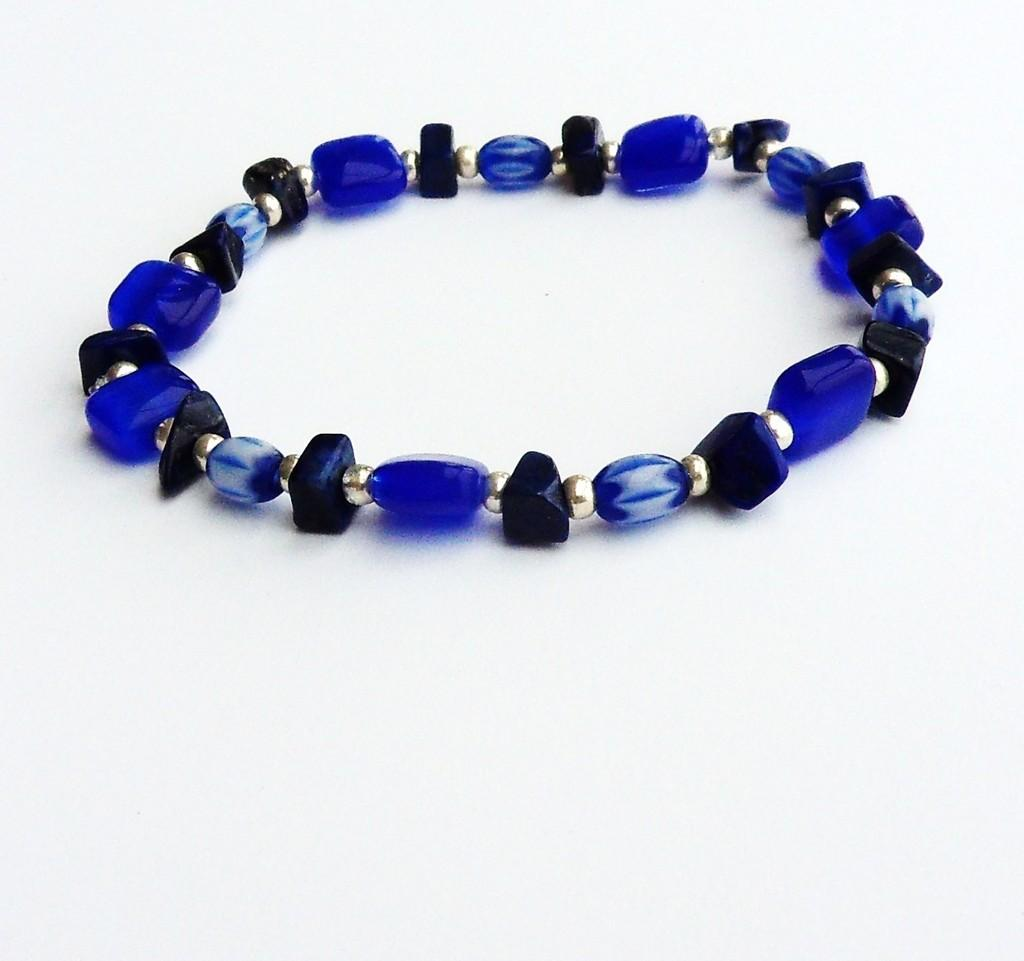What is the main subject of the picture? The main subject of the picture is a bracelet. What color is the bracelet? The bracelet is blue in color. What material is the bracelet made of? The bracelet is made up of silver color beads. What is the color of the background in the picture? The background of the picture is white in color. Can you tell me how many spades are used to create the design of the bracelet? There is no mention of spades being used in the design of the bracelet; it is made up of silver color beads. Is the bracelet being worn on someone's wrist in the image? The image does not show the bracelet being worn on a wrist; it is simply displayed on its own. 